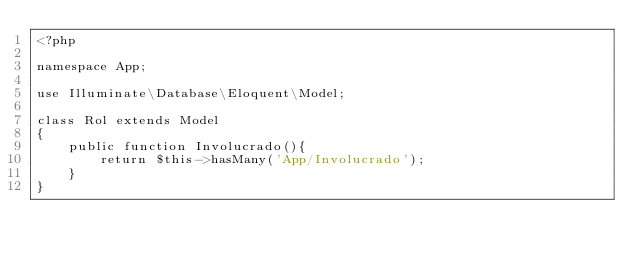Convert code to text. <code><loc_0><loc_0><loc_500><loc_500><_PHP_><?php

namespace App;

use Illuminate\Database\Eloquent\Model;

class Rol extends Model
{
    public function Involucrado(){
        return $this->hasMany('App/Involucrado');
    }
}
</code> 